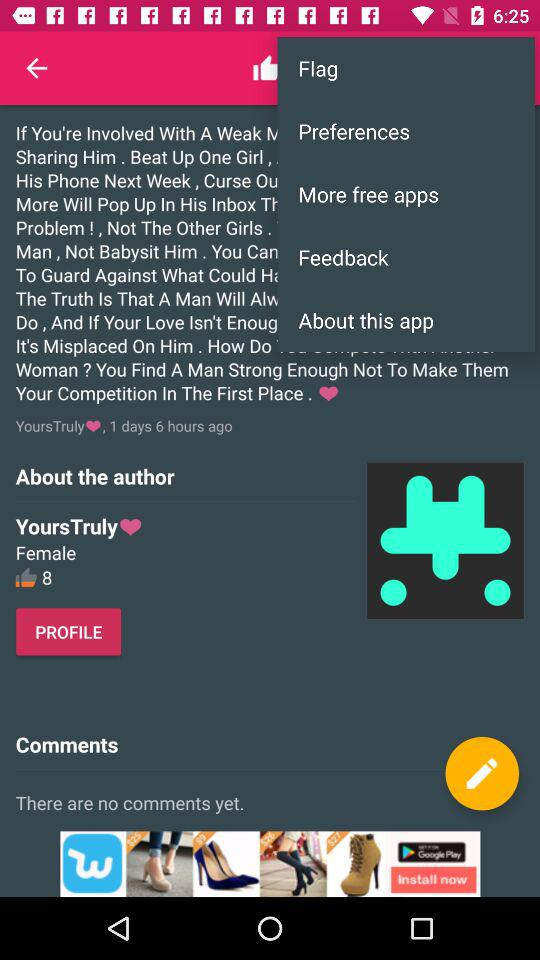What's the username? The username is "YoursTruly". 